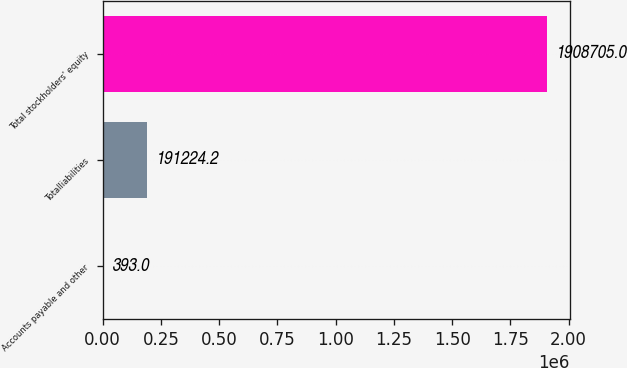<chart> <loc_0><loc_0><loc_500><loc_500><bar_chart><fcel>Accounts payable and other<fcel>Totalliabilities<fcel>Total stockholders' equity<nl><fcel>393<fcel>191224<fcel>1.9087e+06<nl></chart> 